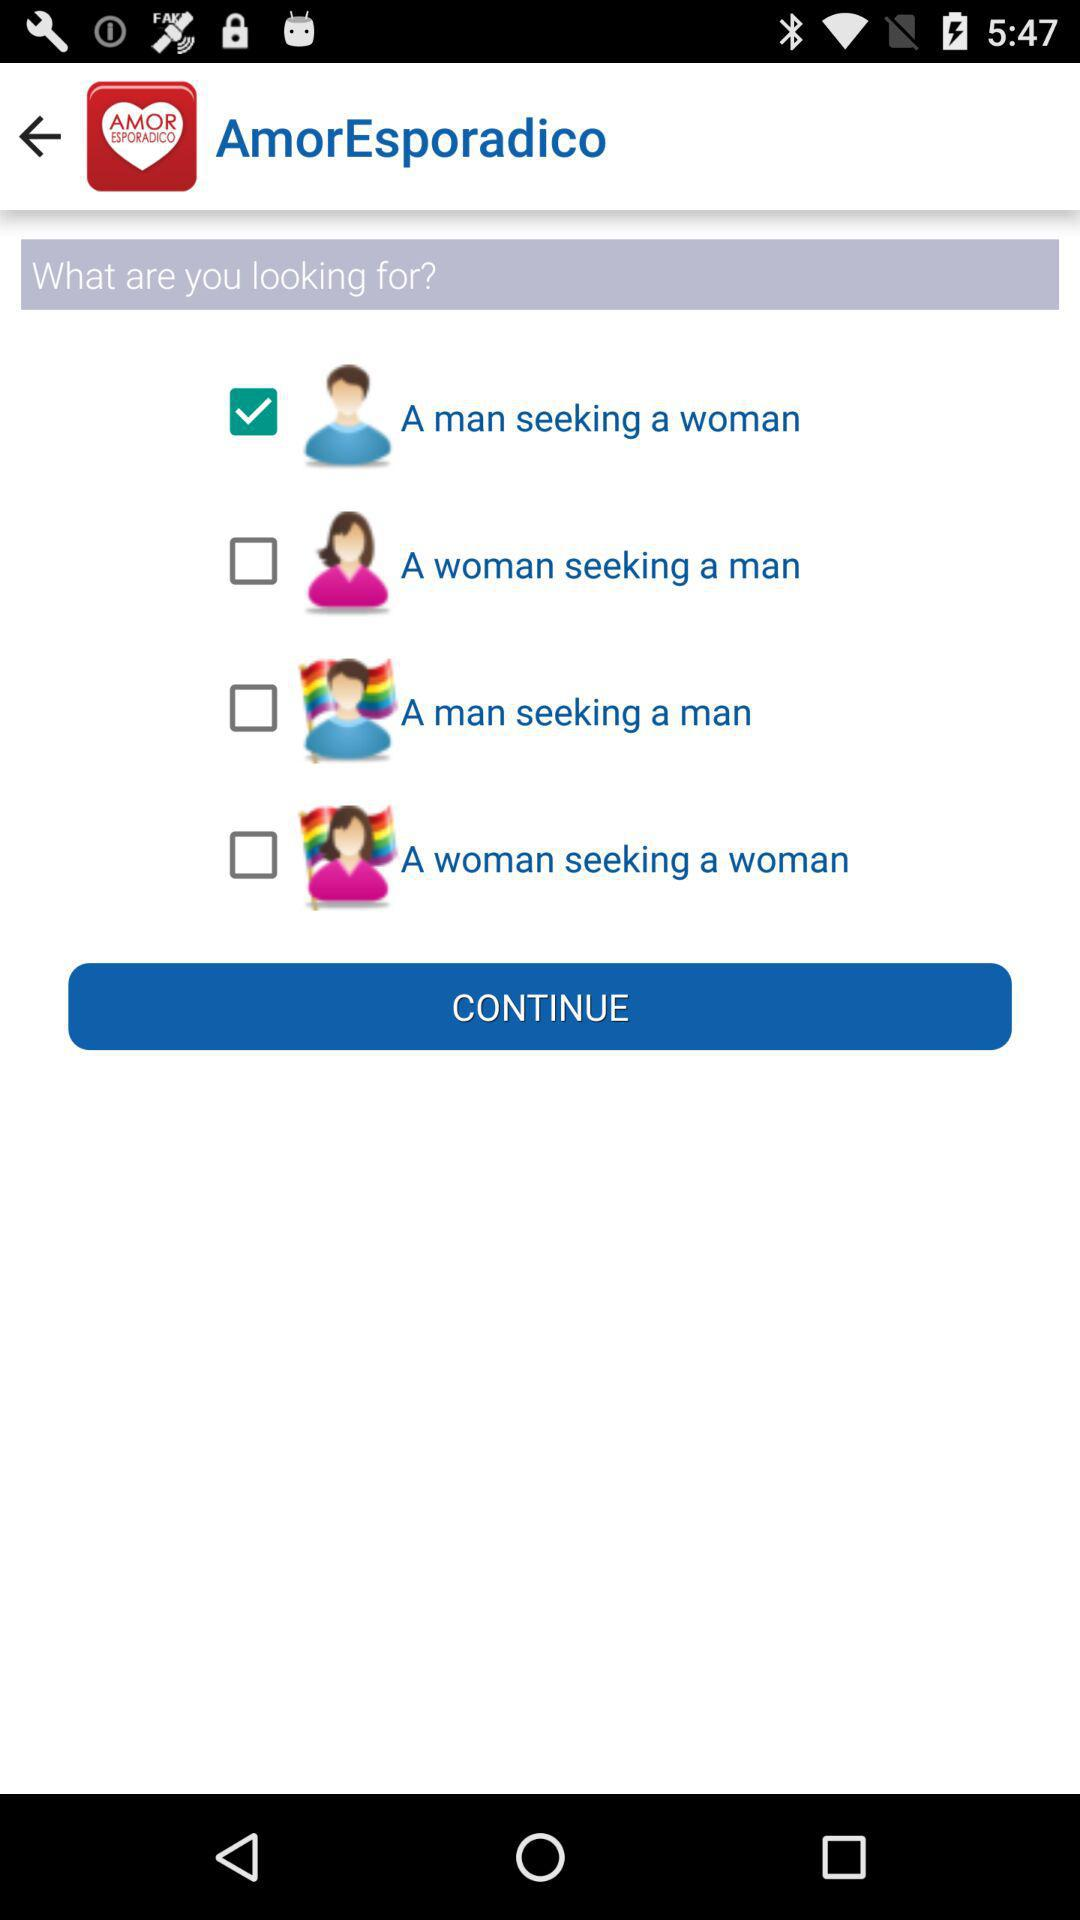Which option has been selected? The selected option is "A man seeking a woman". 